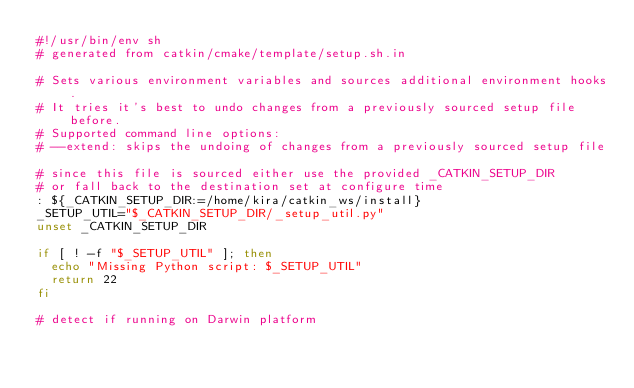Convert code to text. <code><loc_0><loc_0><loc_500><loc_500><_Bash_>#!/usr/bin/env sh
# generated from catkin/cmake/template/setup.sh.in

# Sets various environment variables and sources additional environment hooks.
# It tries it's best to undo changes from a previously sourced setup file before.
# Supported command line options:
# --extend: skips the undoing of changes from a previously sourced setup file

# since this file is sourced either use the provided _CATKIN_SETUP_DIR
# or fall back to the destination set at configure time
: ${_CATKIN_SETUP_DIR:=/home/kira/catkin_ws/install}
_SETUP_UTIL="$_CATKIN_SETUP_DIR/_setup_util.py"
unset _CATKIN_SETUP_DIR

if [ ! -f "$_SETUP_UTIL" ]; then
  echo "Missing Python script: $_SETUP_UTIL"
  return 22
fi

# detect if running on Darwin platform</code> 